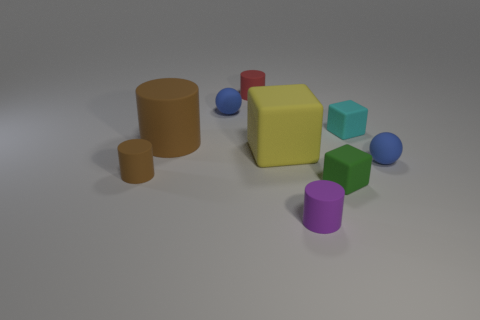Subtract all gray spheres. How many brown cylinders are left? 2 Subtract all tiny cylinders. How many cylinders are left? 1 Subtract all red cylinders. How many cylinders are left? 3 Subtract all cylinders. How many objects are left? 5 Subtract 1 balls. How many balls are left? 1 Subtract all cyan matte cylinders. Subtract all cubes. How many objects are left? 6 Add 9 yellow cubes. How many yellow cubes are left? 10 Add 3 green metallic balls. How many green metallic balls exist? 3 Subtract 0 gray balls. How many objects are left? 9 Subtract all blue cubes. Subtract all gray spheres. How many cubes are left? 3 